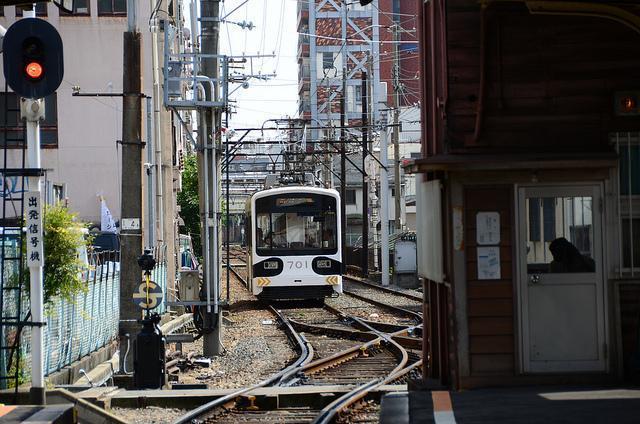How many street lights are there?
Give a very brief answer. 1. 